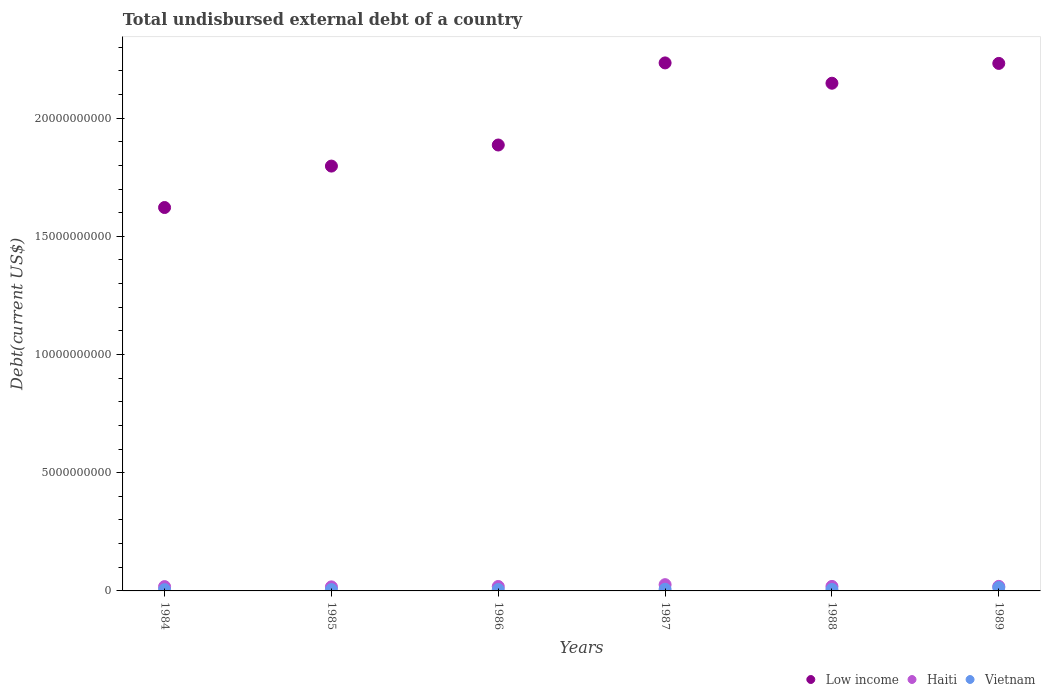Is the number of dotlines equal to the number of legend labels?
Ensure brevity in your answer.  Yes. What is the total undisbursed external debt in Vietnam in 1986?
Provide a succinct answer. 5.86e+07. Across all years, what is the maximum total undisbursed external debt in Low income?
Provide a succinct answer. 2.23e+1. Across all years, what is the minimum total undisbursed external debt in Haiti?
Your response must be concise. 1.72e+08. What is the total total undisbursed external debt in Low income in the graph?
Provide a short and direct response. 1.19e+11. What is the difference between the total undisbursed external debt in Vietnam in 1987 and that in 1988?
Offer a terse response. 8.14e+06. What is the difference between the total undisbursed external debt in Vietnam in 1985 and the total undisbursed external debt in Low income in 1989?
Keep it short and to the point. -2.23e+1. What is the average total undisbursed external debt in Vietnam per year?
Offer a terse response. 7.39e+07. In the year 1985, what is the difference between the total undisbursed external debt in Haiti and total undisbursed external debt in Vietnam?
Your answer should be compact. 1.16e+08. In how many years, is the total undisbursed external debt in Vietnam greater than 7000000000 US$?
Give a very brief answer. 0. What is the ratio of the total undisbursed external debt in Low income in 1984 to that in 1987?
Make the answer very short. 0.73. Is the total undisbursed external debt in Haiti in 1984 less than that in 1985?
Offer a very short reply. No. What is the difference between the highest and the second highest total undisbursed external debt in Vietnam?
Your answer should be very brief. 7.32e+07. What is the difference between the highest and the lowest total undisbursed external debt in Vietnam?
Provide a succinct answer. 8.97e+07. In how many years, is the total undisbursed external debt in Low income greater than the average total undisbursed external debt in Low income taken over all years?
Make the answer very short. 3. Does the total undisbursed external debt in Low income monotonically increase over the years?
Offer a very short reply. No. Is the total undisbursed external debt in Low income strictly less than the total undisbursed external debt in Vietnam over the years?
Your answer should be very brief. No. Are the values on the major ticks of Y-axis written in scientific E-notation?
Provide a short and direct response. No. Where does the legend appear in the graph?
Make the answer very short. Bottom right. How many legend labels are there?
Make the answer very short. 3. What is the title of the graph?
Ensure brevity in your answer.  Total undisbursed external debt of a country. What is the label or title of the Y-axis?
Give a very brief answer. Debt(current US$). What is the Debt(current US$) in Low income in 1984?
Give a very brief answer. 1.62e+1. What is the Debt(current US$) of Haiti in 1984?
Your answer should be compact. 1.82e+08. What is the Debt(current US$) in Vietnam in 1984?
Give a very brief answer. 5.35e+07. What is the Debt(current US$) in Low income in 1985?
Offer a terse response. 1.80e+1. What is the Debt(current US$) in Haiti in 1985?
Provide a succinct answer. 1.72e+08. What is the Debt(current US$) in Vietnam in 1985?
Offer a terse response. 5.60e+07. What is the Debt(current US$) of Low income in 1986?
Your answer should be compact. 1.89e+1. What is the Debt(current US$) in Haiti in 1986?
Ensure brevity in your answer.  1.88e+08. What is the Debt(current US$) in Vietnam in 1986?
Your answer should be compact. 5.86e+07. What is the Debt(current US$) in Low income in 1987?
Keep it short and to the point. 2.23e+1. What is the Debt(current US$) in Haiti in 1987?
Give a very brief answer. 2.65e+08. What is the Debt(current US$) of Vietnam in 1987?
Keep it short and to the point. 7.00e+07. What is the Debt(current US$) of Low income in 1988?
Offer a terse response. 2.15e+1. What is the Debt(current US$) in Haiti in 1988?
Give a very brief answer. 1.91e+08. What is the Debt(current US$) in Vietnam in 1988?
Make the answer very short. 6.19e+07. What is the Debt(current US$) in Low income in 1989?
Give a very brief answer. 2.23e+1. What is the Debt(current US$) of Haiti in 1989?
Your response must be concise. 1.93e+08. What is the Debt(current US$) in Vietnam in 1989?
Your answer should be very brief. 1.43e+08. Across all years, what is the maximum Debt(current US$) of Low income?
Keep it short and to the point. 2.23e+1. Across all years, what is the maximum Debt(current US$) of Haiti?
Offer a terse response. 2.65e+08. Across all years, what is the maximum Debt(current US$) of Vietnam?
Ensure brevity in your answer.  1.43e+08. Across all years, what is the minimum Debt(current US$) of Low income?
Provide a succinct answer. 1.62e+1. Across all years, what is the minimum Debt(current US$) in Haiti?
Your response must be concise. 1.72e+08. Across all years, what is the minimum Debt(current US$) of Vietnam?
Offer a terse response. 5.35e+07. What is the total Debt(current US$) in Low income in the graph?
Provide a succinct answer. 1.19e+11. What is the total Debt(current US$) of Haiti in the graph?
Ensure brevity in your answer.  1.19e+09. What is the total Debt(current US$) of Vietnam in the graph?
Provide a short and direct response. 4.43e+08. What is the difference between the Debt(current US$) of Low income in 1984 and that in 1985?
Keep it short and to the point. -1.75e+09. What is the difference between the Debt(current US$) in Haiti in 1984 and that in 1985?
Keep it short and to the point. 1.06e+07. What is the difference between the Debt(current US$) in Vietnam in 1984 and that in 1985?
Give a very brief answer. -2.56e+06. What is the difference between the Debt(current US$) in Low income in 1984 and that in 1986?
Your answer should be compact. -2.64e+09. What is the difference between the Debt(current US$) in Haiti in 1984 and that in 1986?
Your answer should be very brief. -5.34e+06. What is the difference between the Debt(current US$) in Vietnam in 1984 and that in 1986?
Provide a short and direct response. -5.11e+06. What is the difference between the Debt(current US$) in Low income in 1984 and that in 1987?
Keep it short and to the point. -6.12e+09. What is the difference between the Debt(current US$) of Haiti in 1984 and that in 1987?
Give a very brief answer. -8.23e+07. What is the difference between the Debt(current US$) of Vietnam in 1984 and that in 1987?
Your answer should be compact. -1.66e+07. What is the difference between the Debt(current US$) of Low income in 1984 and that in 1988?
Make the answer very short. -5.26e+09. What is the difference between the Debt(current US$) in Haiti in 1984 and that in 1988?
Ensure brevity in your answer.  -8.19e+06. What is the difference between the Debt(current US$) in Vietnam in 1984 and that in 1988?
Keep it short and to the point. -8.42e+06. What is the difference between the Debt(current US$) in Low income in 1984 and that in 1989?
Your response must be concise. -6.10e+09. What is the difference between the Debt(current US$) in Haiti in 1984 and that in 1989?
Offer a terse response. -1.01e+07. What is the difference between the Debt(current US$) in Vietnam in 1984 and that in 1989?
Provide a short and direct response. -8.97e+07. What is the difference between the Debt(current US$) in Low income in 1985 and that in 1986?
Offer a very short reply. -8.92e+08. What is the difference between the Debt(current US$) of Haiti in 1985 and that in 1986?
Provide a short and direct response. -1.60e+07. What is the difference between the Debt(current US$) in Vietnam in 1985 and that in 1986?
Provide a short and direct response. -2.55e+06. What is the difference between the Debt(current US$) in Low income in 1985 and that in 1987?
Provide a short and direct response. -4.36e+09. What is the difference between the Debt(current US$) in Haiti in 1985 and that in 1987?
Provide a succinct answer. -9.30e+07. What is the difference between the Debt(current US$) in Vietnam in 1985 and that in 1987?
Offer a terse response. -1.40e+07. What is the difference between the Debt(current US$) in Low income in 1985 and that in 1988?
Provide a short and direct response. -3.50e+09. What is the difference between the Debt(current US$) of Haiti in 1985 and that in 1988?
Offer a very short reply. -1.88e+07. What is the difference between the Debt(current US$) of Vietnam in 1985 and that in 1988?
Offer a very short reply. -5.86e+06. What is the difference between the Debt(current US$) in Low income in 1985 and that in 1989?
Your answer should be very brief. -4.34e+09. What is the difference between the Debt(current US$) in Haiti in 1985 and that in 1989?
Ensure brevity in your answer.  -2.08e+07. What is the difference between the Debt(current US$) of Vietnam in 1985 and that in 1989?
Provide a short and direct response. -8.72e+07. What is the difference between the Debt(current US$) of Low income in 1986 and that in 1987?
Ensure brevity in your answer.  -3.47e+09. What is the difference between the Debt(current US$) in Haiti in 1986 and that in 1987?
Make the answer very short. -7.70e+07. What is the difference between the Debt(current US$) in Vietnam in 1986 and that in 1987?
Your answer should be very brief. -1.14e+07. What is the difference between the Debt(current US$) of Low income in 1986 and that in 1988?
Offer a terse response. -2.61e+09. What is the difference between the Debt(current US$) in Haiti in 1986 and that in 1988?
Ensure brevity in your answer.  -2.85e+06. What is the difference between the Debt(current US$) in Vietnam in 1986 and that in 1988?
Keep it short and to the point. -3.31e+06. What is the difference between the Debt(current US$) in Low income in 1986 and that in 1989?
Provide a short and direct response. -3.45e+09. What is the difference between the Debt(current US$) in Haiti in 1986 and that in 1989?
Your answer should be compact. -4.79e+06. What is the difference between the Debt(current US$) in Vietnam in 1986 and that in 1989?
Offer a very short reply. -8.46e+07. What is the difference between the Debt(current US$) in Low income in 1987 and that in 1988?
Offer a very short reply. 8.60e+08. What is the difference between the Debt(current US$) in Haiti in 1987 and that in 1988?
Your answer should be compact. 7.42e+07. What is the difference between the Debt(current US$) of Vietnam in 1987 and that in 1988?
Keep it short and to the point. 8.14e+06. What is the difference between the Debt(current US$) in Low income in 1987 and that in 1989?
Provide a short and direct response. 2.12e+07. What is the difference between the Debt(current US$) in Haiti in 1987 and that in 1989?
Provide a short and direct response. 7.22e+07. What is the difference between the Debt(current US$) in Vietnam in 1987 and that in 1989?
Ensure brevity in your answer.  -7.32e+07. What is the difference between the Debt(current US$) of Low income in 1988 and that in 1989?
Keep it short and to the point. -8.38e+08. What is the difference between the Debt(current US$) in Haiti in 1988 and that in 1989?
Offer a terse response. -1.95e+06. What is the difference between the Debt(current US$) of Vietnam in 1988 and that in 1989?
Your answer should be compact. -8.13e+07. What is the difference between the Debt(current US$) in Low income in 1984 and the Debt(current US$) in Haiti in 1985?
Ensure brevity in your answer.  1.60e+1. What is the difference between the Debt(current US$) of Low income in 1984 and the Debt(current US$) of Vietnam in 1985?
Ensure brevity in your answer.  1.62e+1. What is the difference between the Debt(current US$) in Haiti in 1984 and the Debt(current US$) in Vietnam in 1985?
Provide a short and direct response. 1.26e+08. What is the difference between the Debt(current US$) of Low income in 1984 and the Debt(current US$) of Haiti in 1986?
Ensure brevity in your answer.  1.60e+1. What is the difference between the Debt(current US$) of Low income in 1984 and the Debt(current US$) of Vietnam in 1986?
Give a very brief answer. 1.62e+1. What is the difference between the Debt(current US$) in Haiti in 1984 and the Debt(current US$) in Vietnam in 1986?
Offer a very short reply. 1.24e+08. What is the difference between the Debt(current US$) of Low income in 1984 and the Debt(current US$) of Haiti in 1987?
Make the answer very short. 1.60e+1. What is the difference between the Debt(current US$) of Low income in 1984 and the Debt(current US$) of Vietnam in 1987?
Give a very brief answer. 1.61e+1. What is the difference between the Debt(current US$) of Haiti in 1984 and the Debt(current US$) of Vietnam in 1987?
Ensure brevity in your answer.  1.12e+08. What is the difference between the Debt(current US$) in Low income in 1984 and the Debt(current US$) in Haiti in 1988?
Give a very brief answer. 1.60e+1. What is the difference between the Debt(current US$) of Low income in 1984 and the Debt(current US$) of Vietnam in 1988?
Provide a succinct answer. 1.62e+1. What is the difference between the Debt(current US$) of Haiti in 1984 and the Debt(current US$) of Vietnam in 1988?
Your answer should be compact. 1.21e+08. What is the difference between the Debt(current US$) in Low income in 1984 and the Debt(current US$) in Haiti in 1989?
Offer a terse response. 1.60e+1. What is the difference between the Debt(current US$) of Low income in 1984 and the Debt(current US$) of Vietnam in 1989?
Your answer should be very brief. 1.61e+1. What is the difference between the Debt(current US$) in Haiti in 1984 and the Debt(current US$) in Vietnam in 1989?
Ensure brevity in your answer.  3.92e+07. What is the difference between the Debt(current US$) of Low income in 1985 and the Debt(current US$) of Haiti in 1986?
Give a very brief answer. 1.78e+1. What is the difference between the Debt(current US$) of Low income in 1985 and the Debt(current US$) of Vietnam in 1986?
Ensure brevity in your answer.  1.79e+1. What is the difference between the Debt(current US$) in Haiti in 1985 and the Debt(current US$) in Vietnam in 1986?
Offer a terse response. 1.13e+08. What is the difference between the Debt(current US$) of Low income in 1985 and the Debt(current US$) of Haiti in 1987?
Offer a very short reply. 1.77e+1. What is the difference between the Debt(current US$) in Low income in 1985 and the Debt(current US$) in Vietnam in 1987?
Your answer should be compact. 1.79e+1. What is the difference between the Debt(current US$) of Haiti in 1985 and the Debt(current US$) of Vietnam in 1987?
Provide a succinct answer. 1.02e+08. What is the difference between the Debt(current US$) in Low income in 1985 and the Debt(current US$) in Haiti in 1988?
Offer a terse response. 1.78e+1. What is the difference between the Debt(current US$) of Low income in 1985 and the Debt(current US$) of Vietnam in 1988?
Provide a succinct answer. 1.79e+1. What is the difference between the Debt(current US$) of Haiti in 1985 and the Debt(current US$) of Vietnam in 1988?
Make the answer very short. 1.10e+08. What is the difference between the Debt(current US$) of Low income in 1985 and the Debt(current US$) of Haiti in 1989?
Provide a short and direct response. 1.78e+1. What is the difference between the Debt(current US$) of Low income in 1985 and the Debt(current US$) of Vietnam in 1989?
Your answer should be very brief. 1.78e+1. What is the difference between the Debt(current US$) of Haiti in 1985 and the Debt(current US$) of Vietnam in 1989?
Your answer should be very brief. 2.86e+07. What is the difference between the Debt(current US$) of Low income in 1986 and the Debt(current US$) of Haiti in 1987?
Ensure brevity in your answer.  1.86e+1. What is the difference between the Debt(current US$) in Low income in 1986 and the Debt(current US$) in Vietnam in 1987?
Offer a very short reply. 1.88e+1. What is the difference between the Debt(current US$) of Haiti in 1986 and the Debt(current US$) of Vietnam in 1987?
Ensure brevity in your answer.  1.18e+08. What is the difference between the Debt(current US$) of Low income in 1986 and the Debt(current US$) of Haiti in 1988?
Offer a terse response. 1.87e+1. What is the difference between the Debt(current US$) in Low income in 1986 and the Debt(current US$) in Vietnam in 1988?
Make the answer very short. 1.88e+1. What is the difference between the Debt(current US$) of Haiti in 1986 and the Debt(current US$) of Vietnam in 1988?
Keep it short and to the point. 1.26e+08. What is the difference between the Debt(current US$) in Low income in 1986 and the Debt(current US$) in Haiti in 1989?
Your answer should be very brief. 1.87e+1. What is the difference between the Debt(current US$) in Low income in 1986 and the Debt(current US$) in Vietnam in 1989?
Keep it short and to the point. 1.87e+1. What is the difference between the Debt(current US$) in Haiti in 1986 and the Debt(current US$) in Vietnam in 1989?
Your response must be concise. 4.46e+07. What is the difference between the Debt(current US$) in Low income in 1987 and the Debt(current US$) in Haiti in 1988?
Provide a short and direct response. 2.21e+1. What is the difference between the Debt(current US$) of Low income in 1987 and the Debt(current US$) of Vietnam in 1988?
Give a very brief answer. 2.23e+1. What is the difference between the Debt(current US$) of Haiti in 1987 and the Debt(current US$) of Vietnam in 1988?
Keep it short and to the point. 2.03e+08. What is the difference between the Debt(current US$) in Low income in 1987 and the Debt(current US$) in Haiti in 1989?
Keep it short and to the point. 2.21e+1. What is the difference between the Debt(current US$) of Low income in 1987 and the Debt(current US$) of Vietnam in 1989?
Give a very brief answer. 2.22e+1. What is the difference between the Debt(current US$) in Haiti in 1987 and the Debt(current US$) in Vietnam in 1989?
Provide a succinct answer. 1.22e+08. What is the difference between the Debt(current US$) of Low income in 1988 and the Debt(current US$) of Haiti in 1989?
Make the answer very short. 2.13e+1. What is the difference between the Debt(current US$) in Low income in 1988 and the Debt(current US$) in Vietnam in 1989?
Make the answer very short. 2.13e+1. What is the difference between the Debt(current US$) of Haiti in 1988 and the Debt(current US$) of Vietnam in 1989?
Offer a terse response. 4.74e+07. What is the average Debt(current US$) of Low income per year?
Provide a succinct answer. 1.99e+1. What is the average Debt(current US$) in Haiti per year?
Offer a very short reply. 1.98e+08. What is the average Debt(current US$) in Vietnam per year?
Provide a short and direct response. 7.39e+07. In the year 1984, what is the difference between the Debt(current US$) of Low income and Debt(current US$) of Haiti?
Your answer should be compact. 1.60e+1. In the year 1984, what is the difference between the Debt(current US$) in Low income and Debt(current US$) in Vietnam?
Give a very brief answer. 1.62e+1. In the year 1984, what is the difference between the Debt(current US$) in Haiti and Debt(current US$) in Vietnam?
Offer a terse response. 1.29e+08. In the year 1985, what is the difference between the Debt(current US$) in Low income and Debt(current US$) in Haiti?
Give a very brief answer. 1.78e+1. In the year 1985, what is the difference between the Debt(current US$) in Low income and Debt(current US$) in Vietnam?
Give a very brief answer. 1.79e+1. In the year 1985, what is the difference between the Debt(current US$) of Haiti and Debt(current US$) of Vietnam?
Your answer should be very brief. 1.16e+08. In the year 1986, what is the difference between the Debt(current US$) of Low income and Debt(current US$) of Haiti?
Give a very brief answer. 1.87e+1. In the year 1986, what is the difference between the Debt(current US$) in Low income and Debt(current US$) in Vietnam?
Your answer should be very brief. 1.88e+1. In the year 1986, what is the difference between the Debt(current US$) in Haiti and Debt(current US$) in Vietnam?
Offer a terse response. 1.29e+08. In the year 1987, what is the difference between the Debt(current US$) of Low income and Debt(current US$) of Haiti?
Provide a short and direct response. 2.21e+1. In the year 1987, what is the difference between the Debt(current US$) of Low income and Debt(current US$) of Vietnam?
Ensure brevity in your answer.  2.23e+1. In the year 1987, what is the difference between the Debt(current US$) in Haiti and Debt(current US$) in Vietnam?
Offer a very short reply. 1.95e+08. In the year 1988, what is the difference between the Debt(current US$) of Low income and Debt(current US$) of Haiti?
Your answer should be compact. 2.13e+1. In the year 1988, what is the difference between the Debt(current US$) of Low income and Debt(current US$) of Vietnam?
Make the answer very short. 2.14e+1. In the year 1988, what is the difference between the Debt(current US$) of Haiti and Debt(current US$) of Vietnam?
Provide a short and direct response. 1.29e+08. In the year 1989, what is the difference between the Debt(current US$) of Low income and Debt(current US$) of Haiti?
Give a very brief answer. 2.21e+1. In the year 1989, what is the difference between the Debt(current US$) of Low income and Debt(current US$) of Vietnam?
Ensure brevity in your answer.  2.22e+1. In the year 1989, what is the difference between the Debt(current US$) of Haiti and Debt(current US$) of Vietnam?
Provide a short and direct response. 4.93e+07. What is the ratio of the Debt(current US$) of Low income in 1984 to that in 1985?
Your answer should be very brief. 0.9. What is the ratio of the Debt(current US$) in Haiti in 1984 to that in 1985?
Provide a succinct answer. 1.06. What is the ratio of the Debt(current US$) in Vietnam in 1984 to that in 1985?
Your answer should be very brief. 0.95. What is the ratio of the Debt(current US$) of Low income in 1984 to that in 1986?
Make the answer very short. 0.86. What is the ratio of the Debt(current US$) of Haiti in 1984 to that in 1986?
Your response must be concise. 0.97. What is the ratio of the Debt(current US$) in Vietnam in 1984 to that in 1986?
Your answer should be compact. 0.91. What is the ratio of the Debt(current US$) of Low income in 1984 to that in 1987?
Make the answer very short. 0.73. What is the ratio of the Debt(current US$) of Haiti in 1984 to that in 1987?
Provide a succinct answer. 0.69. What is the ratio of the Debt(current US$) of Vietnam in 1984 to that in 1987?
Provide a succinct answer. 0.76. What is the ratio of the Debt(current US$) of Low income in 1984 to that in 1988?
Offer a terse response. 0.76. What is the ratio of the Debt(current US$) in Haiti in 1984 to that in 1988?
Your response must be concise. 0.96. What is the ratio of the Debt(current US$) of Vietnam in 1984 to that in 1988?
Keep it short and to the point. 0.86. What is the ratio of the Debt(current US$) of Low income in 1984 to that in 1989?
Give a very brief answer. 0.73. What is the ratio of the Debt(current US$) of Vietnam in 1984 to that in 1989?
Your response must be concise. 0.37. What is the ratio of the Debt(current US$) of Low income in 1985 to that in 1986?
Your answer should be very brief. 0.95. What is the ratio of the Debt(current US$) in Haiti in 1985 to that in 1986?
Ensure brevity in your answer.  0.91. What is the ratio of the Debt(current US$) of Vietnam in 1985 to that in 1986?
Offer a very short reply. 0.96. What is the ratio of the Debt(current US$) in Low income in 1985 to that in 1987?
Your response must be concise. 0.8. What is the ratio of the Debt(current US$) in Haiti in 1985 to that in 1987?
Give a very brief answer. 0.65. What is the ratio of the Debt(current US$) of Vietnam in 1985 to that in 1987?
Offer a very short reply. 0.8. What is the ratio of the Debt(current US$) of Low income in 1985 to that in 1988?
Your response must be concise. 0.84. What is the ratio of the Debt(current US$) of Haiti in 1985 to that in 1988?
Give a very brief answer. 0.9. What is the ratio of the Debt(current US$) of Vietnam in 1985 to that in 1988?
Your response must be concise. 0.91. What is the ratio of the Debt(current US$) of Low income in 1985 to that in 1989?
Make the answer very short. 0.81. What is the ratio of the Debt(current US$) in Haiti in 1985 to that in 1989?
Keep it short and to the point. 0.89. What is the ratio of the Debt(current US$) in Vietnam in 1985 to that in 1989?
Make the answer very short. 0.39. What is the ratio of the Debt(current US$) in Low income in 1986 to that in 1987?
Offer a very short reply. 0.84. What is the ratio of the Debt(current US$) in Haiti in 1986 to that in 1987?
Provide a succinct answer. 0.71. What is the ratio of the Debt(current US$) in Vietnam in 1986 to that in 1987?
Your answer should be compact. 0.84. What is the ratio of the Debt(current US$) of Low income in 1986 to that in 1988?
Ensure brevity in your answer.  0.88. What is the ratio of the Debt(current US$) of Haiti in 1986 to that in 1988?
Your answer should be very brief. 0.99. What is the ratio of the Debt(current US$) of Vietnam in 1986 to that in 1988?
Make the answer very short. 0.95. What is the ratio of the Debt(current US$) in Low income in 1986 to that in 1989?
Provide a succinct answer. 0.85. What is the ratio of the Debt(current US$) of Haiti in 1986 to that in 1989?
Provide a succinct answer. 0.98. What is the ratio of the Debt(current US$) of Vietnam in 1986 to that in 1989?
Give a very brief answer. 0.41. What is the ratio of the Debt(current US$) of Low income in 1987 to that in 1988?
Provide a short and direct response. 1.04. What is the ratio of the Debt(current US$) of Haiti in 1987 to that in 1988?
Your response must be concise. 1.39. What is the ratio of the Debt(current US$) in Vietnam in 1987 to that in 1988?
Offer a terse response. 1.13. What is the ratio of the Debt(current US$) in Low income in 1987 to that in 1989?
Give a very brief answer. 1. What is the ratio of the Debt(current US$) in Haiti in 1987 to that in 1989?
Offer a very short reply. 1.38. What is the ratio of the Debt(current US$) of Vietnam in 1987 to that in 1989?
Your answer should be very brief. 0.49. What is the ratio of the Debt(current US$) in Low income in 1988 to that in 1989?
Make the answer very short. 0.96. What is the ratio of the Debt(current US$) of Vietnam in 1988 to that in 1989?
Your response must be concise. 0.43. What is the difference between the highest and the second highest Debt(current US$) of Low income?
Ensure brevity in your answer.  2.12e+07. What is the difference between the highest and the second highest Debt(current US$) of Haiti?
Your response must be concise. 7.22e+07. What is the difference between the highest and the second highest Debt(current US$) in Vietnam?
Make the answer very short. 7.32e+07. What is the difference between the highest and the lowest Debt(current US$) in Low income?
Give a very brief answer. 6.12e+09. What is the difference between the highest and the lowest Debt(current US$) of Haiti?
Your answer should be very brief. 9.30e+07. What is the difference between the highest and the lowest Debt(current US$) in Vietnam?
Offer a very short reply. 8.97e+07. 